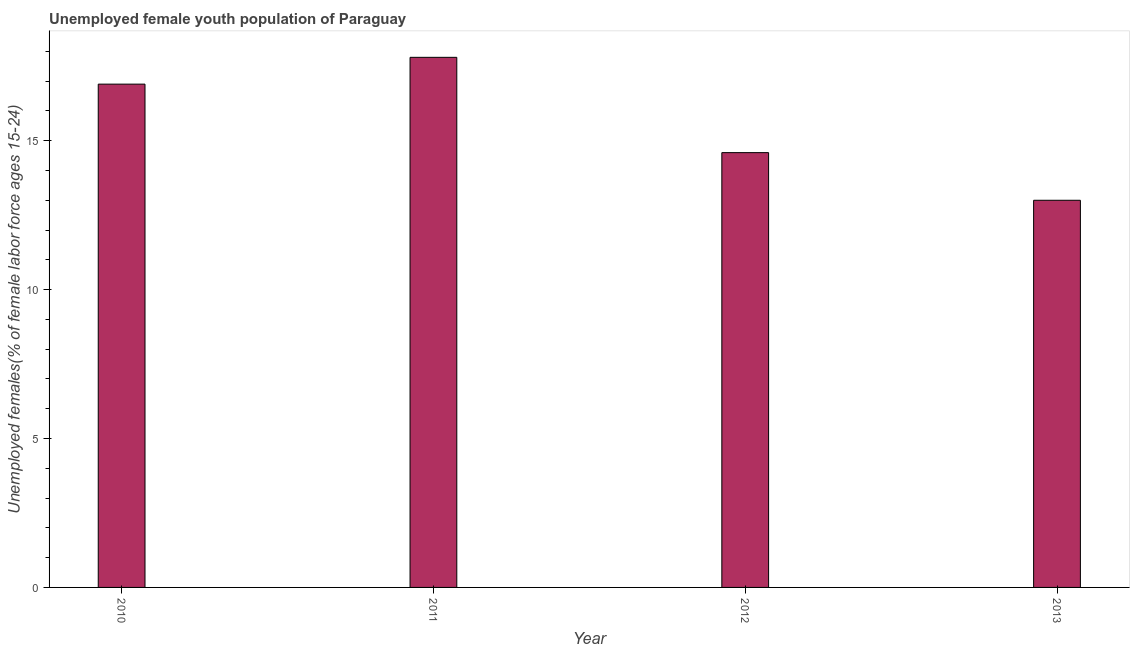What is the title of the graph?
Keep it short and to the point. Unemployed female youth population of Paraguay. What is the label or title of the Y-axis?
Make the answer very short. Unemployed females(% of female labor force ages 15-24). What is the unemployed female youth in 2011?
Ensure brevity in your answer.  17.8. Across all years, what is the maximum unemployed female youth?
Provide a short and direct response. 17.8. Across all years, what is the minimum unemployed female youth?
Your answer should be compact. 13. In which year was the unemployed female youth maximum?
Your answer should be very brief. 2011. In which year was the unemployed female youth minimum?
Offer a terse response. 2013. What is the sum of the unemployed female youth?
Provide a succinct answer. 62.3. What is the difference between the unemployed female youth in 2011 and 2013?
Offer a terse response. 4.8. What is the average unemployed female youth per year?
Provide a short and direct response. 15.57. What is the median unemployed female youth?
Your answer should be compact. 15.75. In how many years, is the unemployed female youth greater than 2 %?
Your answer should be compact. 4. Do a majority of the years between 2010 and 2013 (inclusive) have unemployed female youth greater than 12 %?
Give a very brief answer. Yes. What is the ratio of the unemployed female youth in 2010 to that in 2012?
Give a very brief answer. 1.16. Is the unemployed female youth in 2011 less than that in 2013?
Your response must be concise. No. Is the difference between the unemployed female youth in 2011 and 2012 greater than the difference between any two years?
Offer a very short reply. No. What is the difference between the highest and the lowest unemployed female youth?
Your answer should be compact. 4.8. What is the Unemployed females(% of female labor force ages 15-24) of 2010?
Make the answer very short. 16.9. What is the Unemployed females(% of female labor force ages 15-24) of 2011?
Your answer should be compact. 17.8. What is the Unemployed females(% of female labor force ages 15-24) in 2012?
Ensure brevity in your answer.  14.6. What is the Unemployed females(% of female labor force ages 15-24) in 2013?
Your answer should be compact. 13. What is the difference between the Unemployed females(% of female labor force ages 15-24) in 2010 and 2011?
Give a very brief answer. -0.9. What is the difference between the Unemployed females(% of female labor force ages 15-24) in 2010 and 2012?
Ensure brevity in your answer.  2.3. What is the difference between the Unemployed females(% of female labor force ages 15-24) in 2010 and 2013?
Your response must be concise. 3.9. What is the difference between the Unemployed females(% of female labor force ages 15-24) in 2011 and 2013?
Provide a short and direct response. 4.8. What is the ratio of the Unemployed females(% of female labor force ages 15-24) in 2010 to that in 2011?
Provide a succinct answer. 0.95. What is the ratio of the Unemployed females(% of female labor force ages 15-24) in 2010 to that in 2012?
Provide a succinct answer. 1.16. What is the ratio of the Unemployed females(% of female labor force ages 15-24) in 2010 to that in 2013?
Your answer should be very brief. 1.3. What is the ratio of the Unemployed females(% of female labor force ages 15-24) in 2011 to that in 2012?
Offer a terse response. 1.22. What is the ratio of the Unemployed females(% of female labor force ages 15-24) in 2011 to that in 2013?
Your answer should be very brief. 1.37. What is the ratio of the Unemployed females(% of female labor force ages 15-24) in 2012 to that in 2013?
Offer a very short reply. 1.12. 